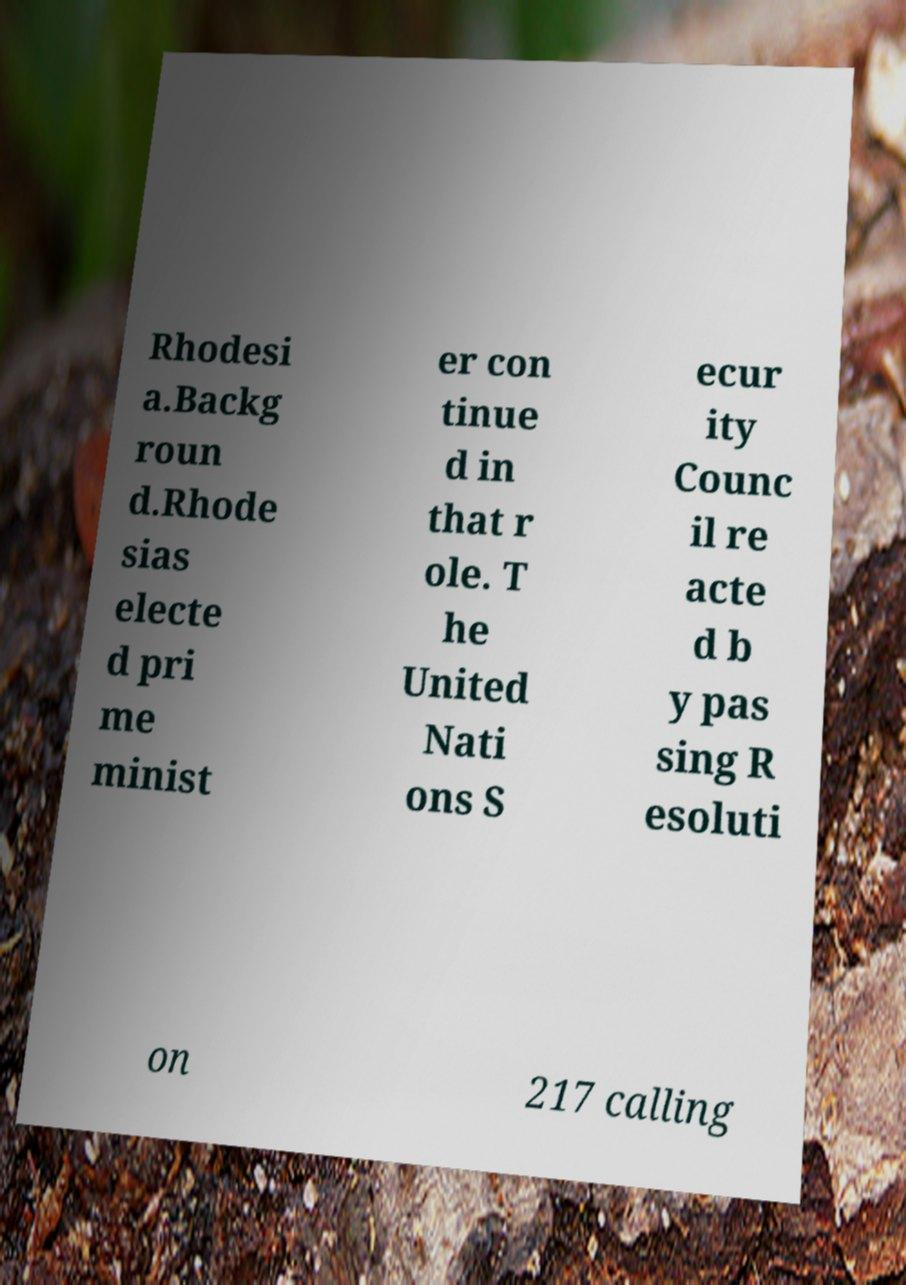I need the written content from this picture converted into text. Can you do that? Rhodesi a.Backg roun d.Rhode sias electe d pri me minist er con tinue d in that r ole. T he United Nati ons S ecur ity Counc il re acte d b y pas sing R esoluti on 217 calling 